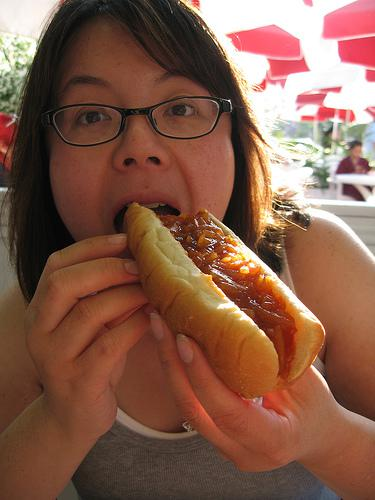Question: what is on the person's face?
Choices:
A. Makeup.
B. Face paint.
C. Sunglasses.
D. Glasses.
Answer with the letter. Answer: D Question: how many fingers are showing on the person's right hand?
Choices:
A. 4.
B. 12.
C. 13.
D. 5.
Answer with the letter. Answer: A Question: when did the person begin eating the hot dog?
Choices:
A. Hasn't started yet.
B. Just began.
C. 5 minutes ago.
D. Right now.
Answer with the letter. Answer: B Question: why is the person's mouth open?
Choices:
A. Taking a bite of food.
B. Laughing.
C. To eat.
D. Chewing food.
Answer with the letter. Answer: C Question: where is the person holding the hot dog?
Choices:
A. In front of face.
B. Sitting at a table.
C. Standing  nearby.
D. Sitting in a chair.
Answer with the letter. Answer: A Question: who is eating?
Choices:
A. The person long hair.
B. The woman.
C. A teenager.
D. A lady with long hair.
Answer with the letter. Answer: A 